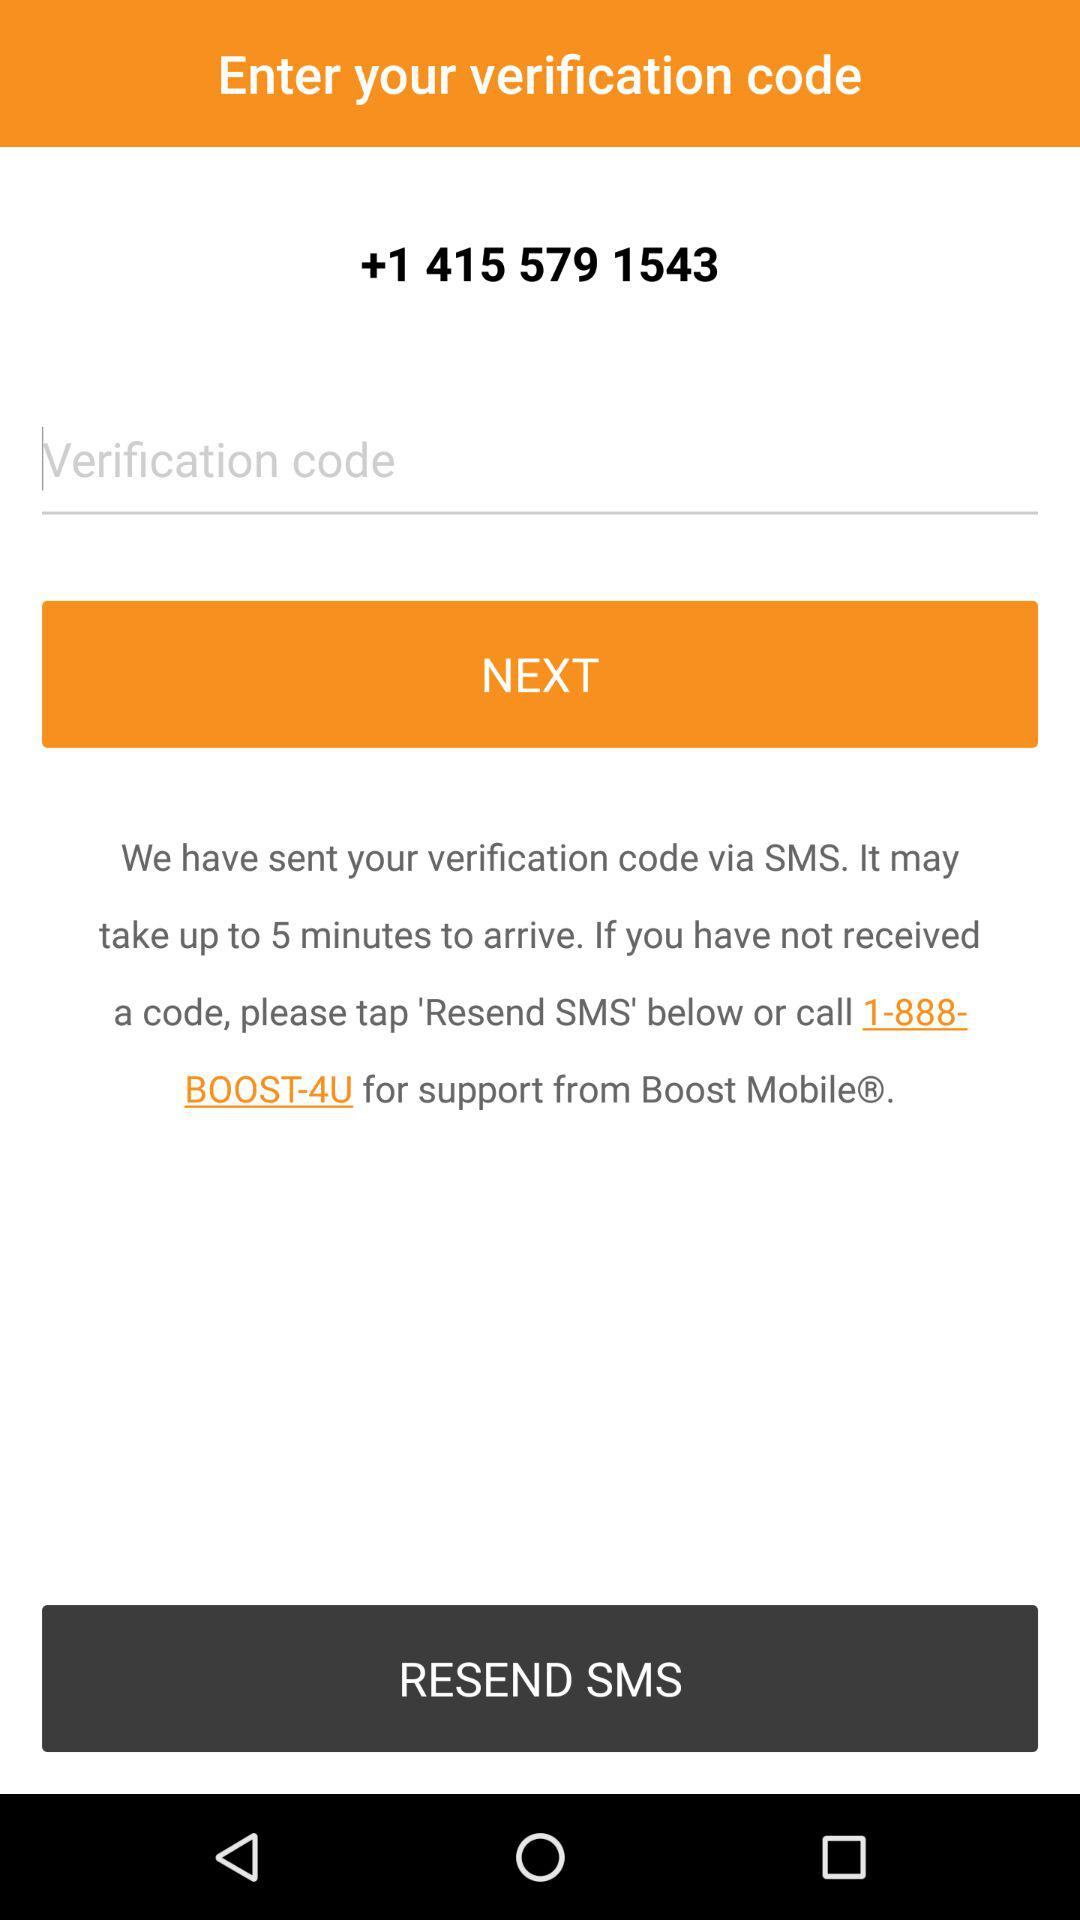Through what mode has the verification code been sent? The verification code has been sent via SMS. 